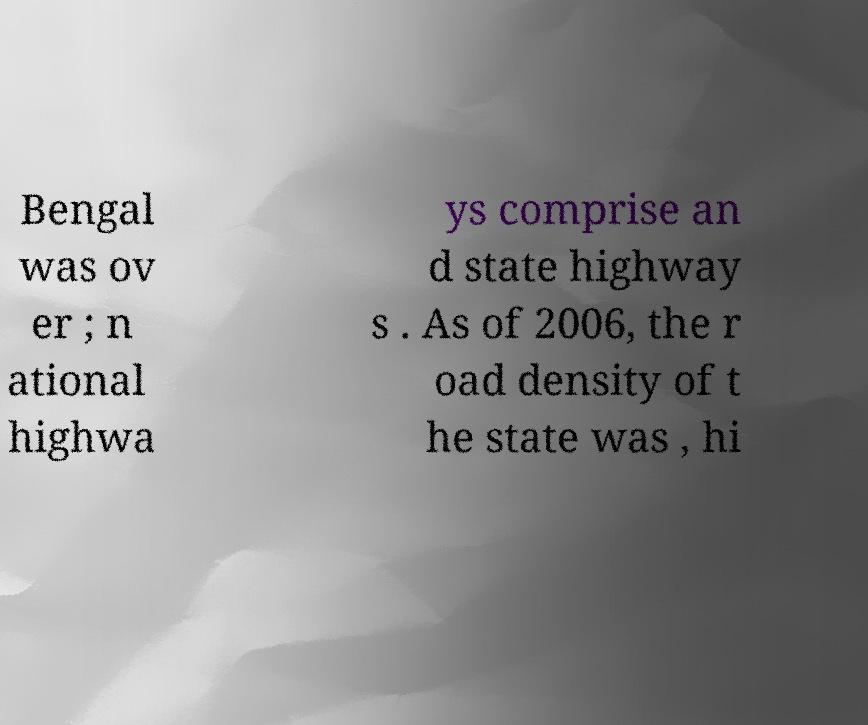Please read and relay the text visible in this image. What does it say? Bengal was ov er ; n ational highwa ys comprise an d state highway s . As of 2006, the r oad density of t he state was , hi 